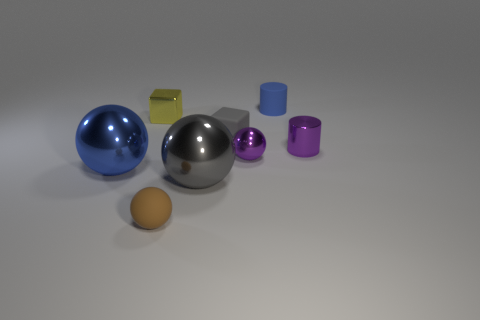There is a rubber thing that is right of the tiny gray rubber thing; what is its color?
Offer a terse response. Blue. Is the color of the tiny cylinder in front of the small blue matte cylinder the same as the tiny metal sphere?
Provide a short and direct response. Yes. What size is the gray metal object that is the same shape as the brown matte object?
Your response must be concise. Large. The purple object that is in front of the tiny purple metal thing behind the sphere right of the big gray shiny object is made of what material?
Your answer should be very brief. Metal. Are there more tiny purple metallic things that are on the right side of the blue metallic sphere than matte cylinders in front of the matte cube?
Make the answer very short. Yes. Is the gray metal ball the same size as the blue metal object?
Your answer should be compact. Yes. The other small metal thing that is the same shape as the small brown thing is what color?
Give a very brief answer. Purple. How many large spheres have the same color as the rubber cylinder?
Keep it short and to the point. 1. Are there more tiny objects to the right of the yellow metallic block than big cyan balls?
Provide a short and direct response. Yes. What color is the tiny cylinder to the left of the small object to the right of the blue matte cylinder?
Your response must be concise. Blue. 